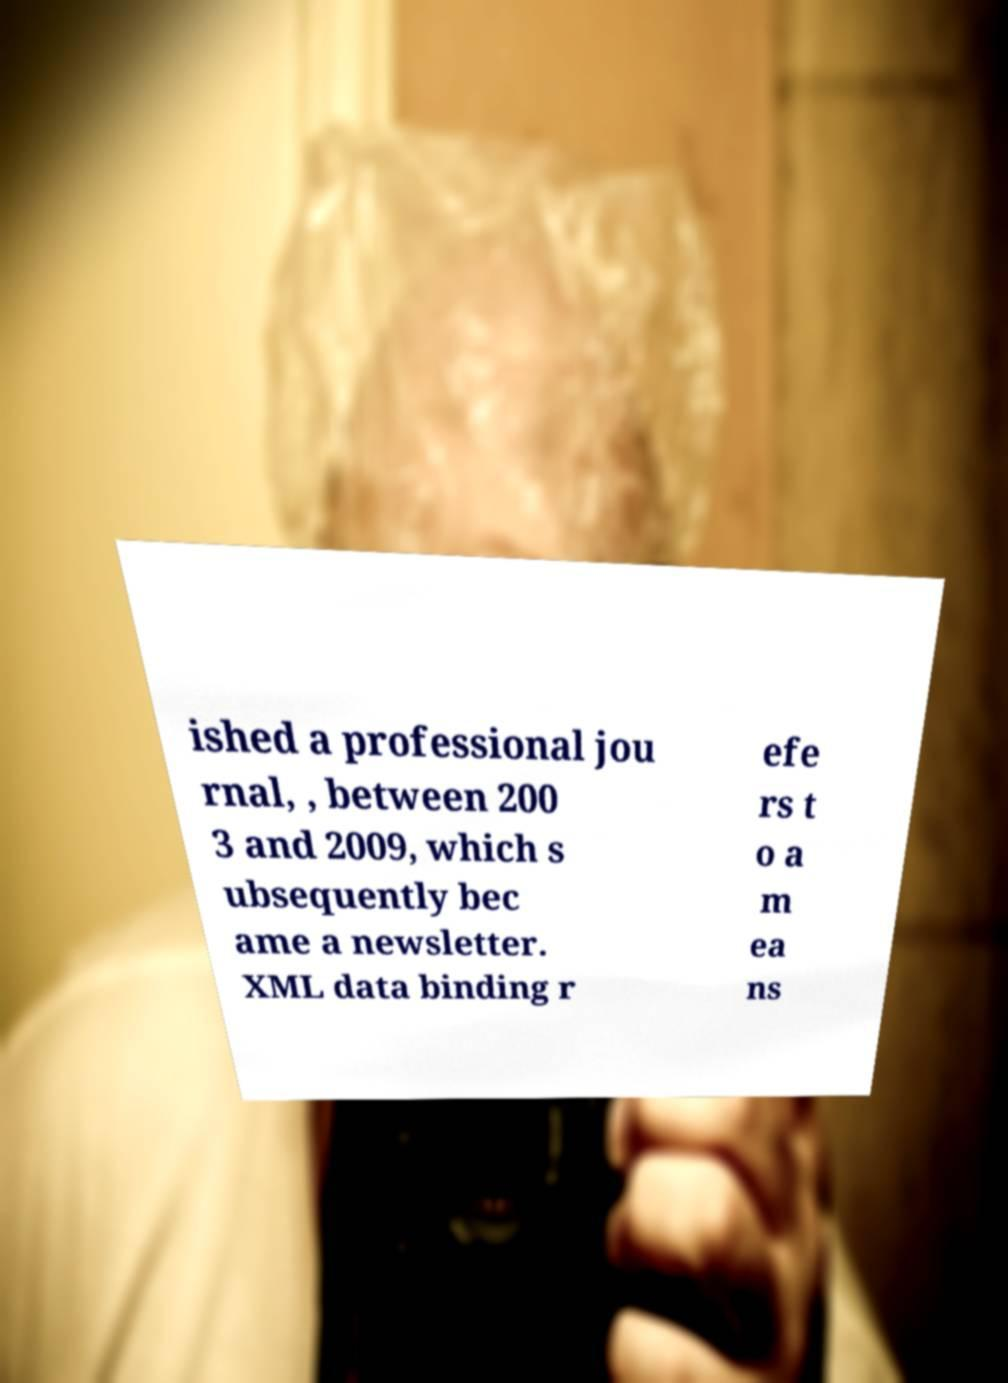I need the written content from this picture converted into text. Can you do that? ished a professional jou rnal, , between 200 3 and 2009, which s ubsequently bec ame a newsletter. XML data binding r efe rs t o a m ea ns 